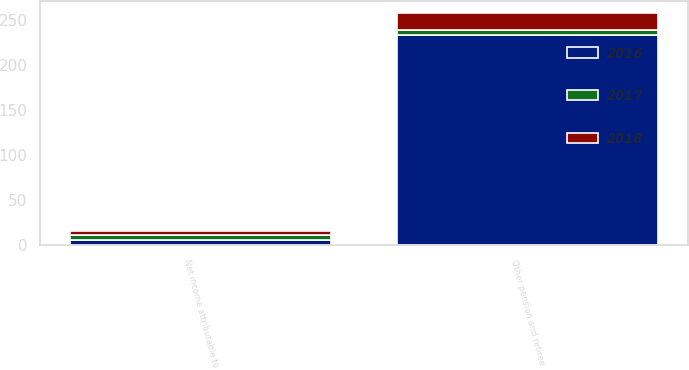<chart> <loc_0><loc_0><loc_500><loc_500><stacked_bar_chart><ecel><fcel>Other pension and retiree<fcel>Net income attributable to<nl><fcel>2017<fcel>5.445<fcel>5.66<nl><fcel>2016<fcel>233<fcel>5.23<nl><fcel>2018<fcel>19<fcel>4.85<nl></chart> 